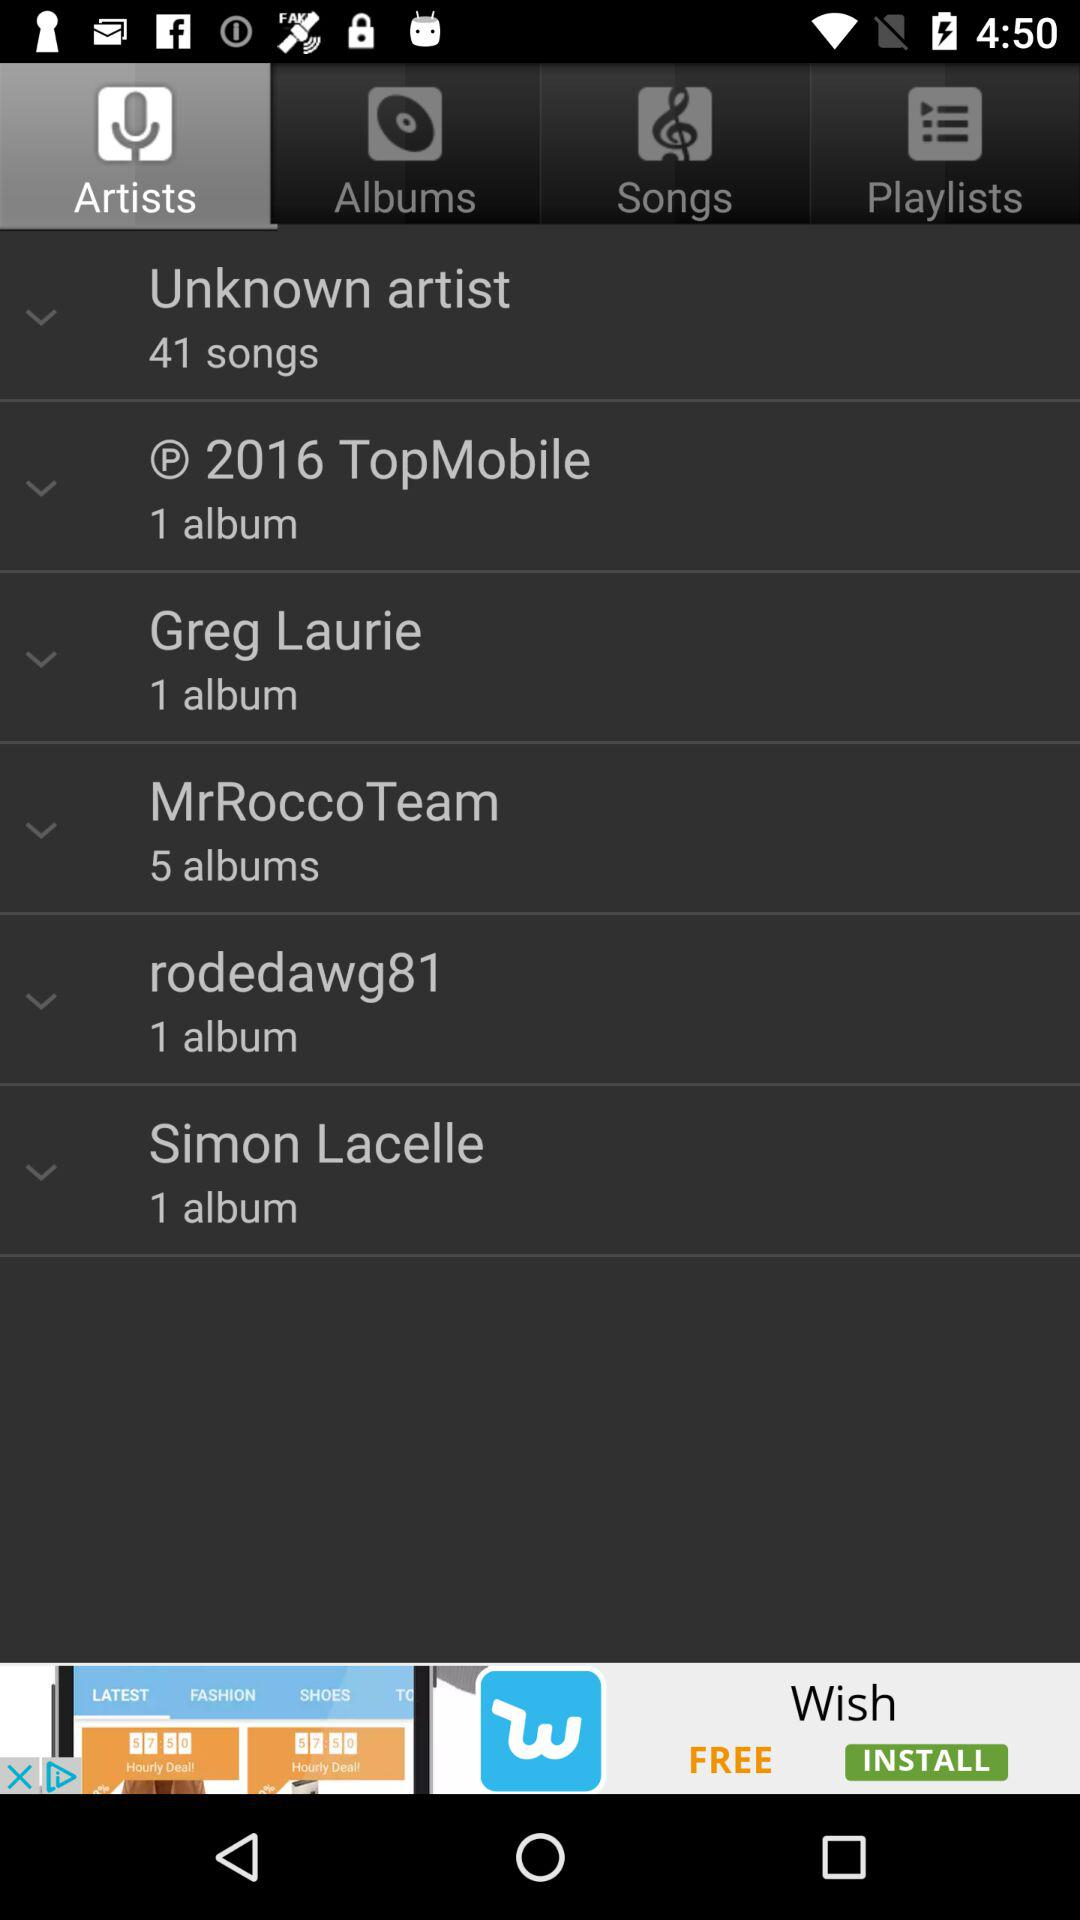How many songs are there by an unknown artist? There are 41 songs by an unknown artist. 